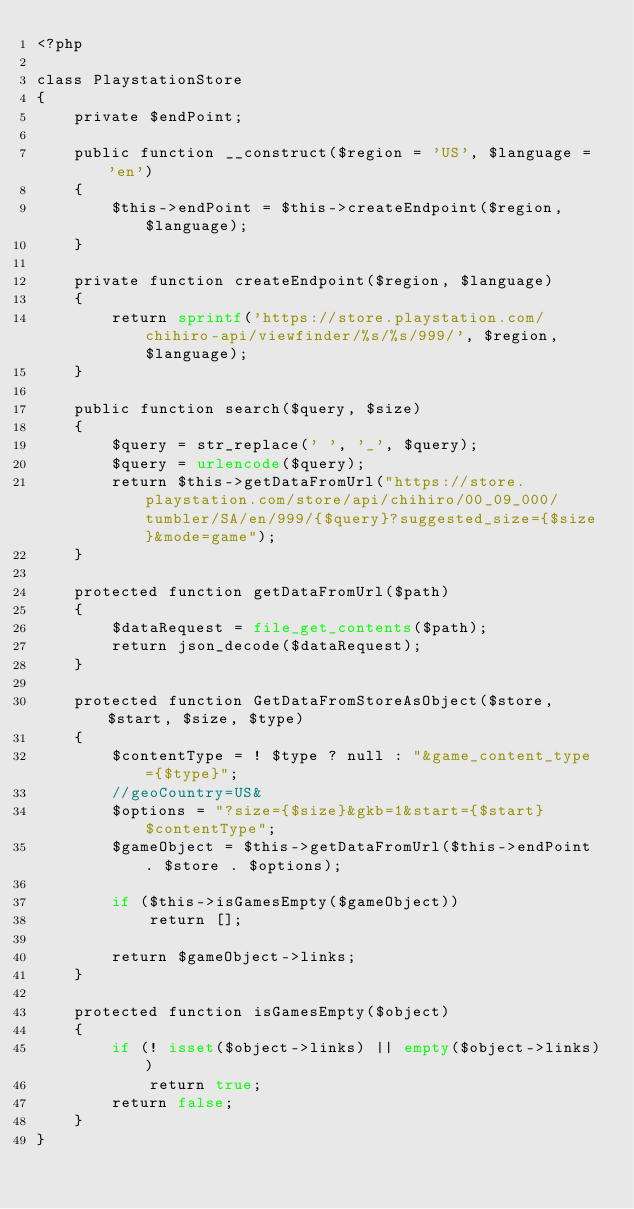Convert code to text. <code><loc_0><loc_0><loc_500><loc_500><_PHP_><?php

class PlaystationStore
{
    private $endPoint;

    public function __construct($region = 'US', $language = 'en')
    {
        $this->endPoint = $this->createEndpoint($region, $language);
    }

    private function createEndpoint($region, $language)
    {
        return sprintf('https://store.playstation.com/chihiro-api/viewfinder/%s/%s/999/', $region, $language);
    }

    public function search($query, $size)
    {
        $query = str_replace(' ', '_', $query);
        $query = urlencode($query);
        return $this->getDataFromUrl("https://store.playstation.com/store/api/chihiro/00_09_000/tumbler/SA/en/999/{$query}?suggested_size={$size}&mode=game");
    }

    protected function getDataFromUrl($path)
    {
        $dataRequest = file_get_contents($path);
        return json_decode($dataRequest);
    }

    protected function GetDataFromStoreAsObject($store, $start, $size, $type)
    {
        $contentType = ! $type ? null : "&game_content_type={$type}";
        //geoCountry=US&
        $options = "?size={$size}&gkb=1&start={$start}$contentType";
        $gameObject = $this->getDataFromUrl($this->endPoint . $store . $options);

        if ($this->isGamesEmpty($gameObject))
            return [];

        return $gameObject->links;
    }

    protected function isGamesEmpty($object)
    {
        if (! isset($object->links) || empty($object->links))
            return true;
        return false;
    }
}</code> 